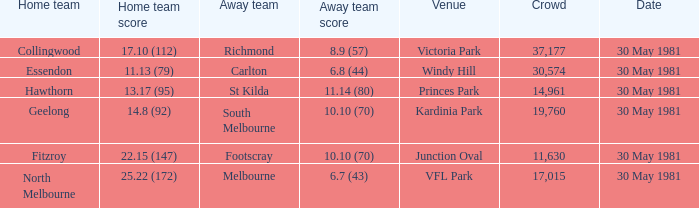What did carlton score while away? 6.8 (44). 